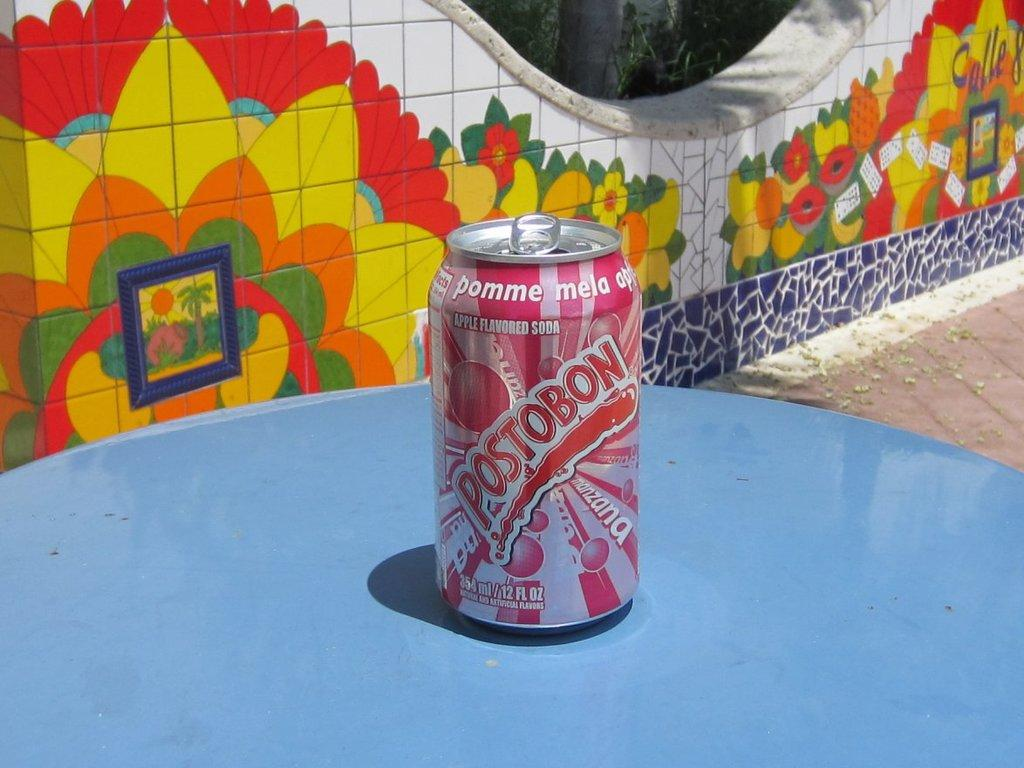<image>
Summarize the visual content of the image. a can of postobon that is on a blue surface 